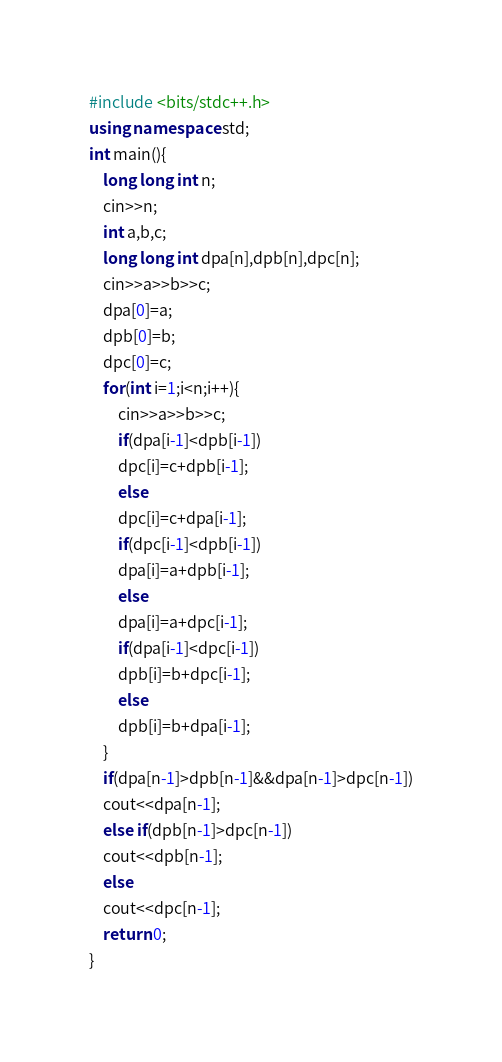<code> <loc_0><loc_0><loc_500><loc_500><_C++_>#include <bits/stdc++.h>
using namespace std;
int main(){
    long long int n;
    cin>>n;
    int a,b,c;
    long long int dpa[n],dpb[n],dpc[n];
    cin>>a>>b>>c;
    dpa[0]=a;
    dpb[0]=b;
    dpc[0]=c;
    for(int i=1;i<n;i++){
        cin>>a>>b>>c;
        if(dpa[i-1]<dpb[i-1])
        dpc[i]=c+dpb[i-1];
        else
        dpc[i]=c+dpa[i-1];
        if(dpc[i-1]<dpb[i-1])
        dpa[i]=a+dpb[i-1];
        else
        dpa[i]=a+dpc[i-1];
        if(dpa[i-1]<dpc[i-1])
        dpb[i]=b+dpc[i-1];
        else
        dpb[i]=b+dpa[i-1];
    }
    if(dpa[n-1]>dpb[n-1]&&dpa[n-1]>dpc[n-1])
    cout<<dpa[n-1];
    else if(dpb[n-1]>dpc[n-1])
    cout<<dpb[n-1];
    else
    cout<<dpc[n-1];
    return 0;
}</code> 